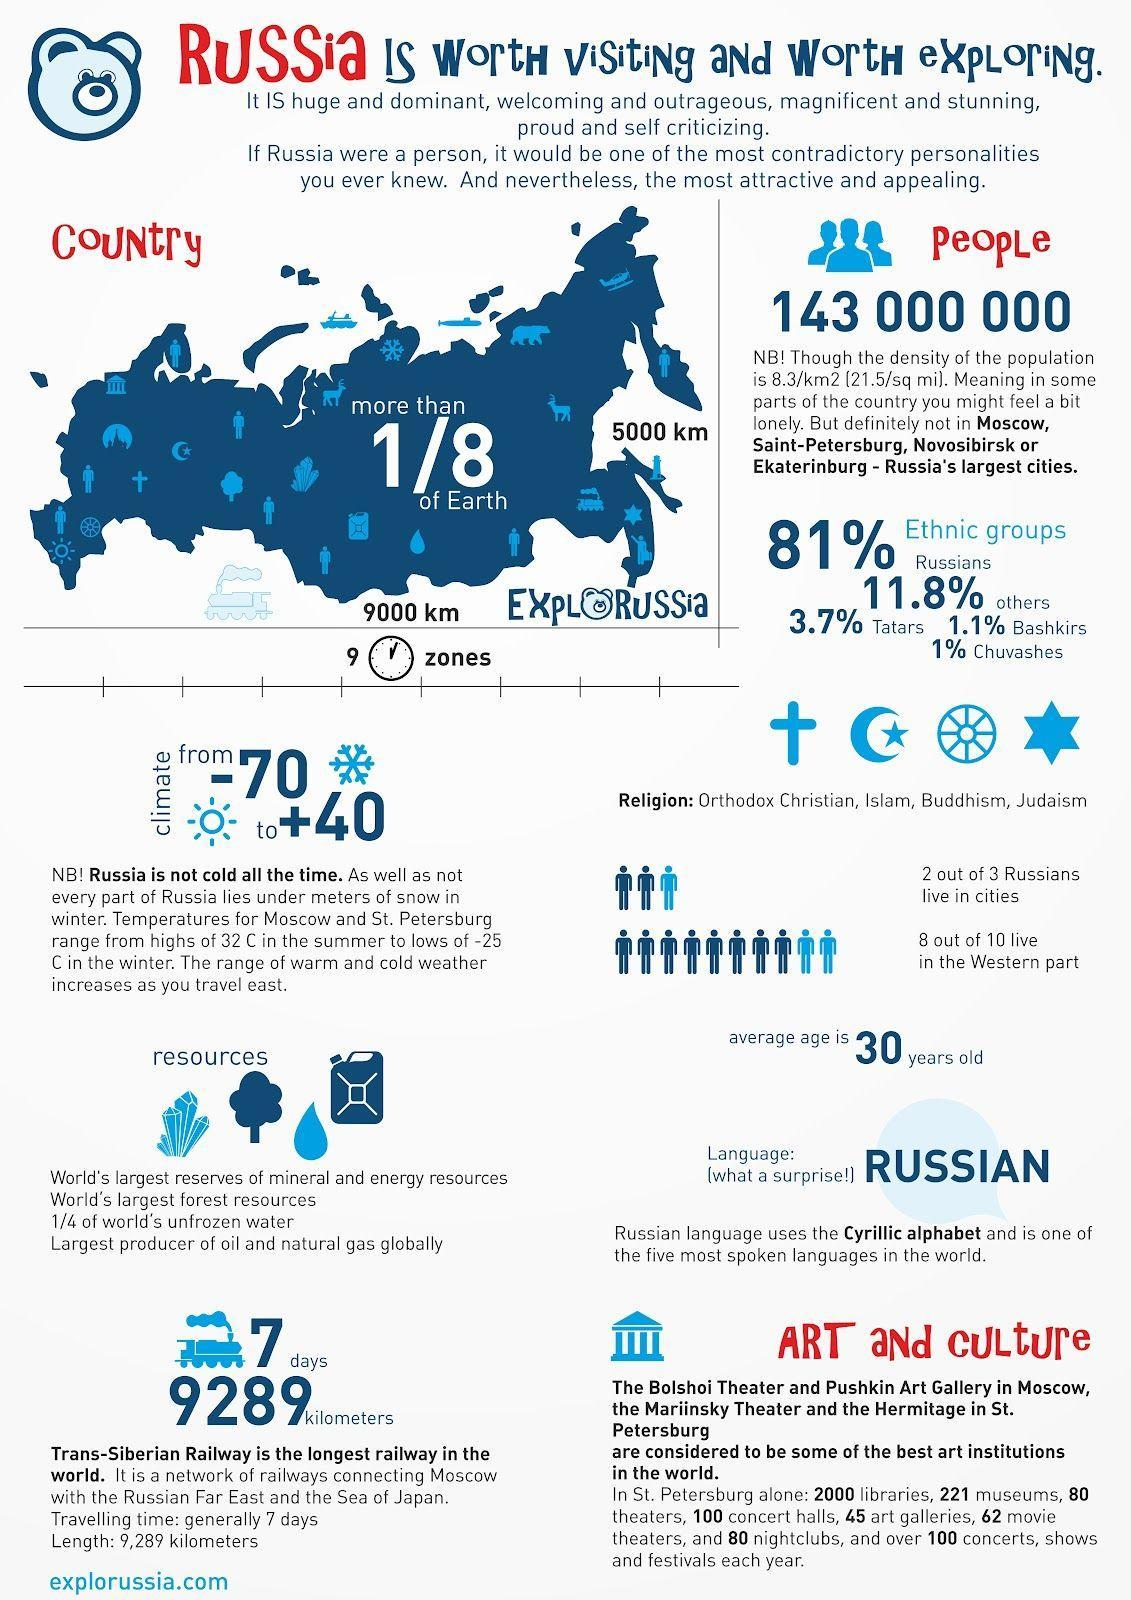What is the percentage of Tatars and Chuvashes, taken together?
Answer the question with a short phrase. 4.7% Out of 3, how many Russians not lives in cities? 1 How many religions are in Russia? 5 What is the number of theaters and nightclubs in St.Petersburg, taken together? 160 Out of 10, how many not live in the western part? 2 